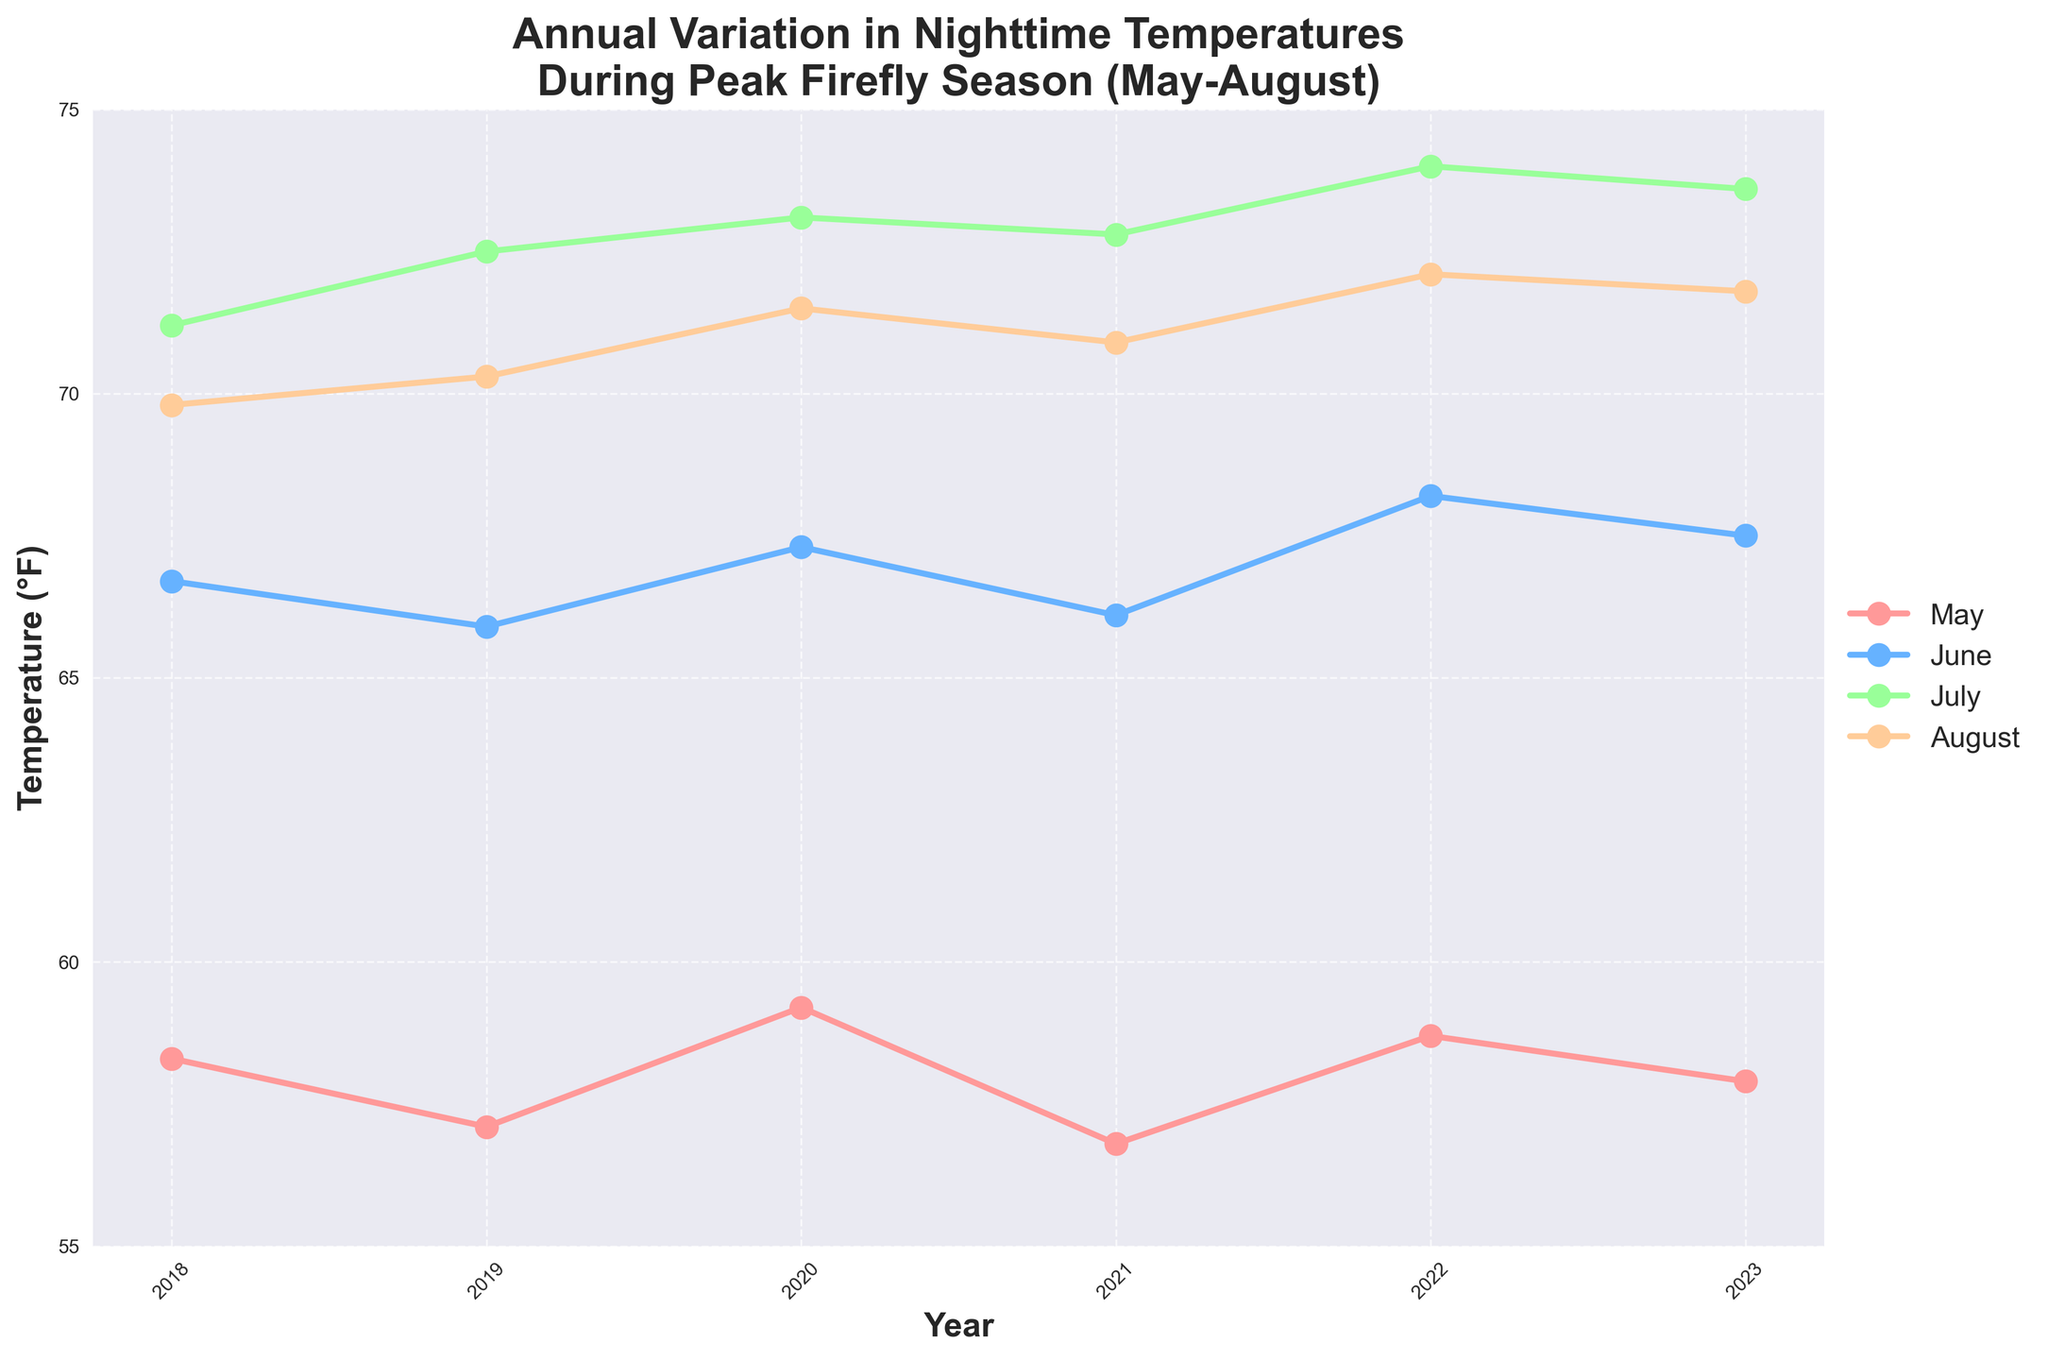What's the average nighttime temperature in June over the specified years? First, add the June temperatures for each year: 66.7 (2018), 65.9 (2019), 67.3 (2020), 66.1 (2021), 68.2 (2022), and 67.5 (2023). The sum is 401.7. Then, divide by the number of years, which is 6: 401.7 / 6 = 66.95
Answer: 66.95 Which month experienced the highest temperature in 2022? Looking at the 2022 data points on the line chart, we see the temperatures in May, June, July, and August are 58.7, 68.2, 74.0, and 72.1 respectively. July has the highest temperature at 74.0°F.
Answer: July In which year was the nighttime temperature in May the lowest? By comparing the May temperatures across all years on the chart, the lowest value is for 2021 which has a temperature of 56.8°F.
Answer: 2021 Compare the temperatures of July and August in 2019. Which one is higher? From the 2019 data points, the nighttime temperature in July is 72.5°F and in August is 70.3°F. Since 72.5°F is greater than 70.3°F, the July temperature is higher.
Answer: July What is the change in August nighttime temperatures from 2018 to 2023? The August temperature in 2018 is 69.8°F and in 2023 is 71.8°F. The change is found by subtracting the earlier value from the later value: 71.8 - 69.8 = 2.0°F
Answer: 2.0°F Which year had the smallest difference between May and August temperatures? Calculate the difference between May and August for each year:
2018: 69.8 - 58.3 = 11.5
2019: 70.3 - 57.1 = 13.2
2020: 71.5 - 59.2 = 12.3
2021: 70.9 - 56.8 = 14.1
2022: 72.1 - 58.7 = 13.4
2023: 71.8 - 57.9 = 13.9
2018 has the smallest difference of 11.5
Answer: 2018 Which month shows the most consistent temperatures (least variation) across the years? Calculate the range (max - min) for each month:
May: 59.2 - 56.8 = 2.4
June: 68.2 - 65.9 = 2.3
July: 74.0 - 71.2 = 2.8
August: 72.1 - 69.8 = 2.3
June and August both have the least variation with a range of 2.3°F.
Answer: June and August What is the overall trend of nighttime temperatures in July from 2018 to 2023? Observing the July temperature points: 71.2 (2018), 72.5 (2019), 73.1 (2020), 72.8 (2021), 74.0 (2022), and 73.6 (2023), we can see that July temperatures generally increase over the years.
Answer: Increasing 